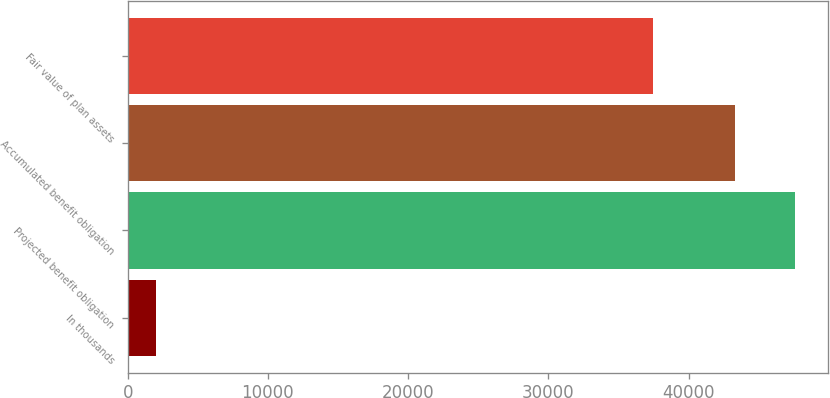<chart> <loc_0><loc_0><loc_500><loc_500><bar_chart><fcel>In thousands<fcel>Projected benefit obligation<fcel>Accumulated benefit obligation<fcel>Fair value of plan assets<nl><fcel>2017<fcel>47559.6<fcel>43340<fcel>37432<nl></chart> 